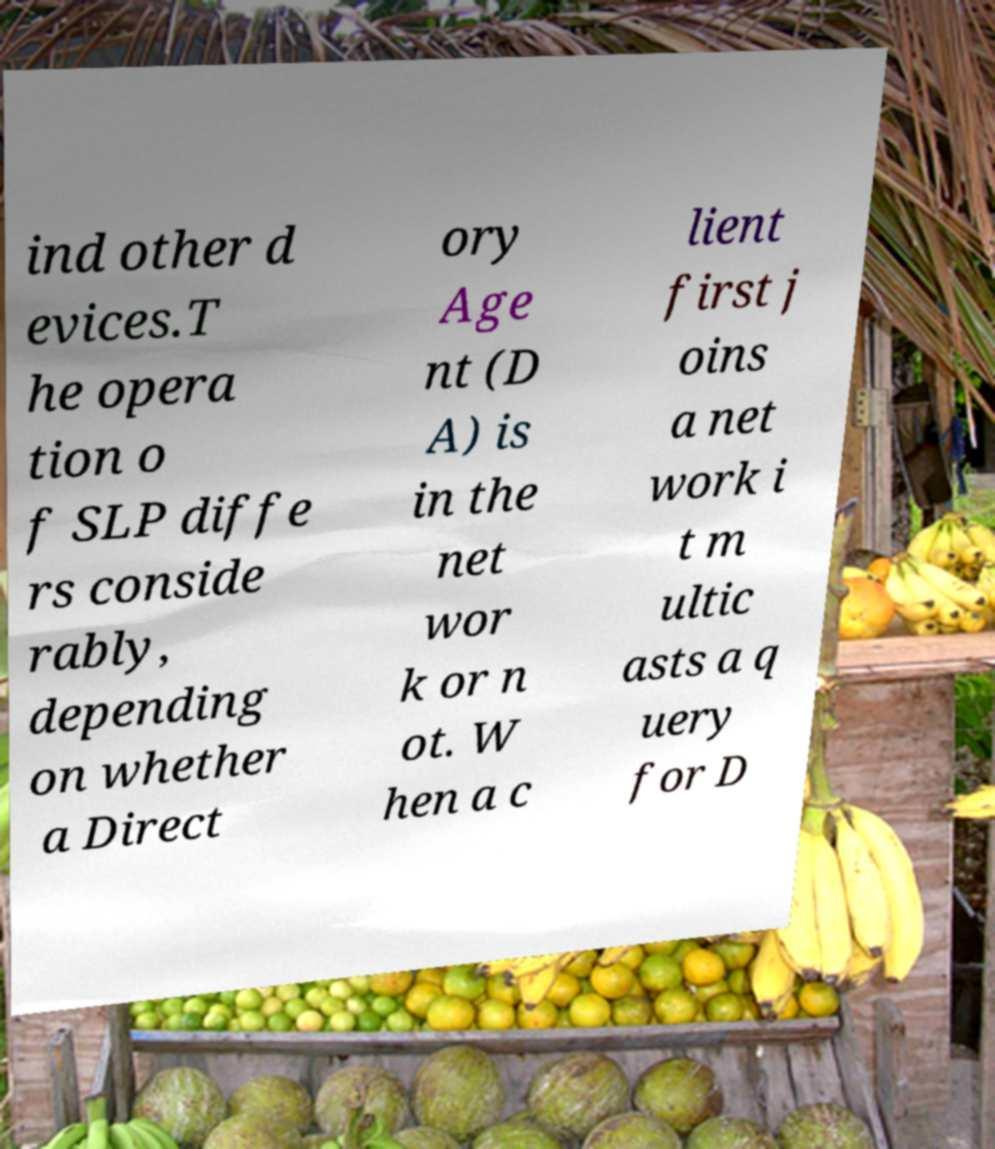Could you extract and type out the text from this image? ind other d evices.T he opera tion o f SLP diffe rs conside rably, depending on whether a Direct ory Age nt (D A) is in the net wor k or n ot. W hen a c lient first j oins a net work i t m ultic asts a q uery for D 